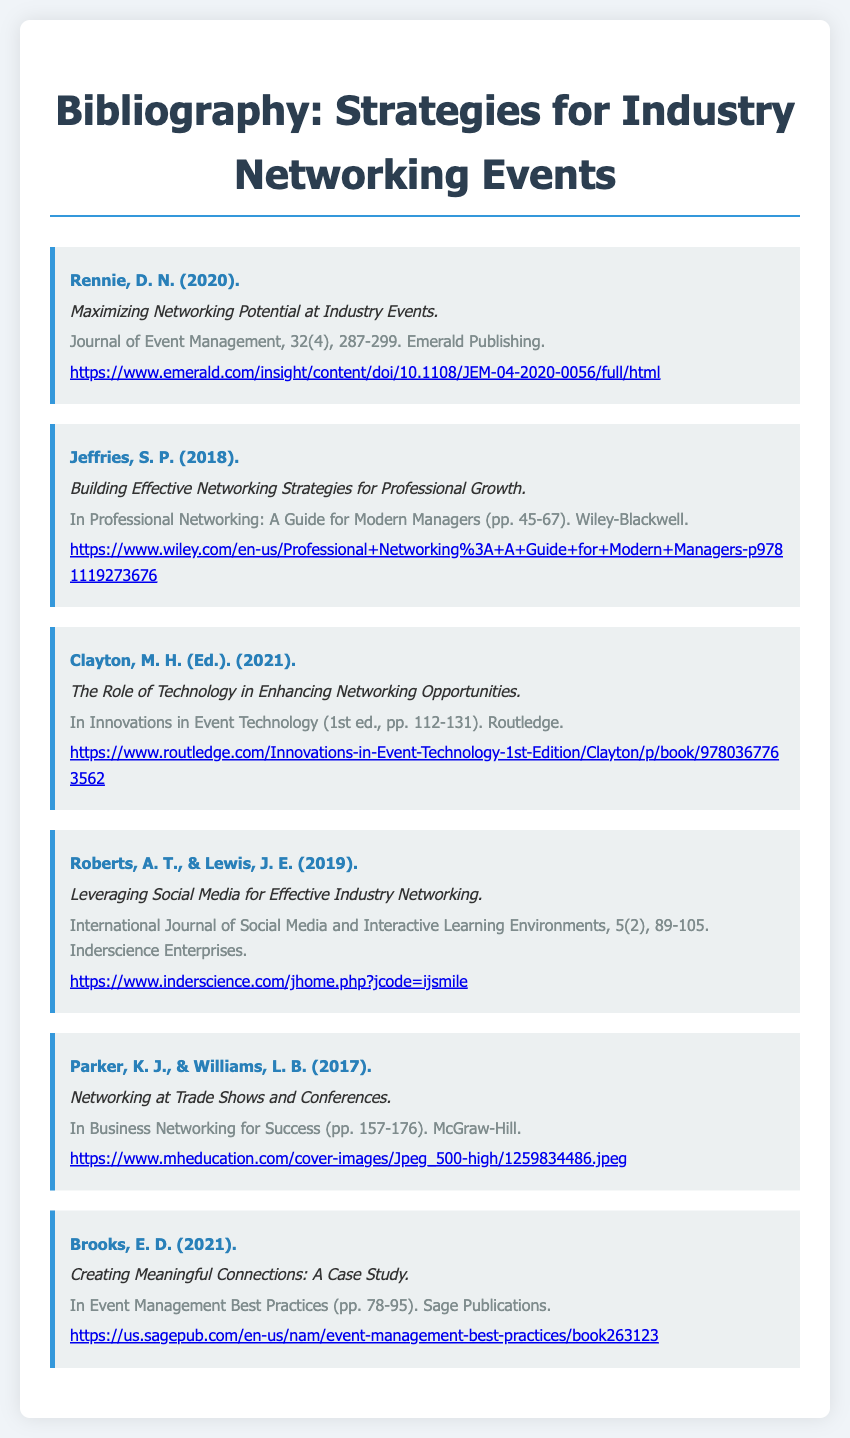what is the title of the first item in the bibliography? The title of the first item is presented as the focus of the citation.
Answer: Maximizing Networking Potential at Industry Events who is the author of the third bibliography item? The author's name is typically listed at the beginning of each citation, which helps identify the source.
Answer: Clayton, M. H in what year was the second item published? The publication year is included in parentheses directly after the author's name, indicating when the work was released.
Answer: 2018 what page range does the fifth item cover? The page range is usually provided in parentheses after the title and indicates the section in the book or journal where this work can be found.
Answer: 78-95 which publication is the item authored by Roberts and Lewis found in? The specific journal in which the work is published is typically listed after the title and the page numbers, providing the context of the contribution.
Answer: International Journal of Social Media and Interactive Learning Environments how many authors contributed to the fourth bibliography item? The number of authors is specified at the beginning of the citation, influencing how the work is referenced or quoted.
Answer: Two what is the primary subject of the bibliography items? The bibliography items collectively focus on methods and strategies aimed at networking within industry-related events.
Answer: Networking Strategies which publisher released the book mentioned in the third item? The publisher is indicated at the end of each entry, giving insight into who is responsible for distributing the work.
Answer: Routledge what is the range of pages for the last entry? The page range can be found in parentheses and is crucial for knowing where to find the referenced information within the publication.
Answer: 157-176 